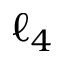Convert formula to latex. <formula><loc_0><loc_0><loc_500><loc_500>\ell _ { 4 }</formula> 